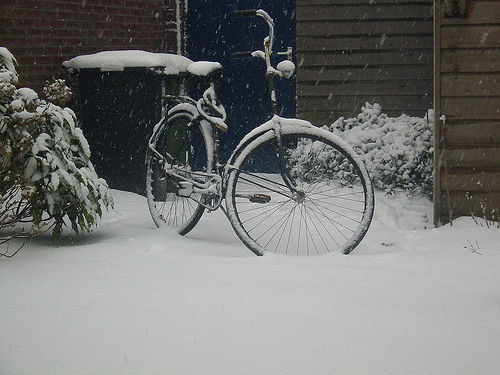Are the texture details of the bicycle rich and clear? The texture details of the bicycle are relatively clear, despite the snowy conditions. The image resolution and lighting allow us to discern the individual snowflakes adorning the bicycle's frame and wheels, as well as the patterns on the bike's metal surfaces. Nevertheless, the snow cover does obscure some finer details. 